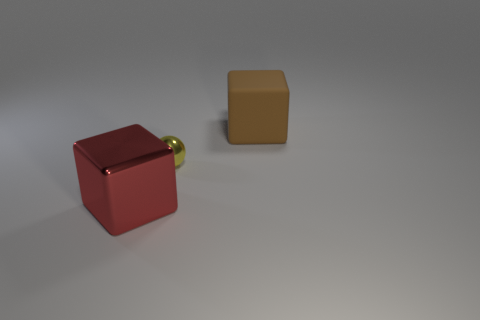Add 2 big red metal cubes. How many objects exist? 5 Subtract all cubes. How many objects are left? 1 Subtract all large purple rubber cylinders. Subtract all small balls. How many objects are left? 2 Add 2 rubber cubes. How many rubber cubes are left? 3 Add 3 cyan rubber cylinders. How many cyan rubber cylinders exist? 3 Subtract 0 red cylinders. How many objects are left? 3 